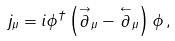Convert formula to latex. <formula><loc_0><loc_0><loc_500><loc_500>j _ { \mu } = i \phi ^ { \dagger } \left ( \stackrel { \rightarrow } { \partial } _ { \mu } - \stackrel { \leftarrow } { \partial } _ { \mu } \right ) \phi \, ,</formula> 